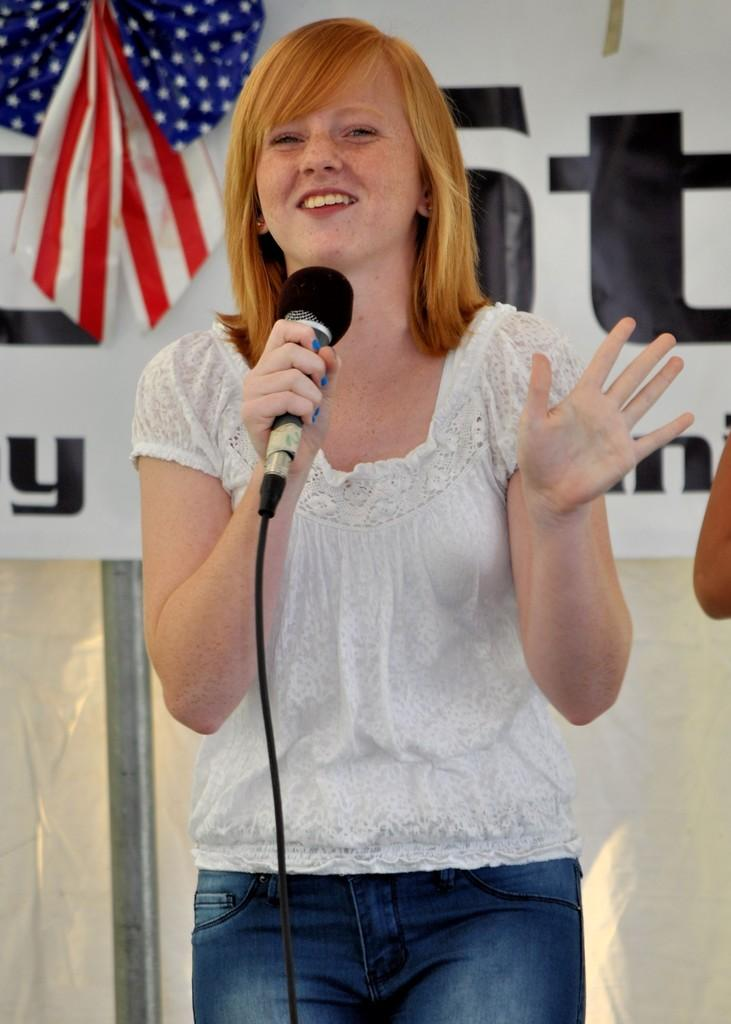What is the main subject of the image? The main subject of the image is a woman. What is the woman doing in the image? The woman is standing and talking into a microphone. What can be seen in the background of the image? There is a flag, a banner, and another person standing in the background of the image. What type of horn can be heard in the background of the image? There is no horn present in the image, and therefore no sound can be heard. 